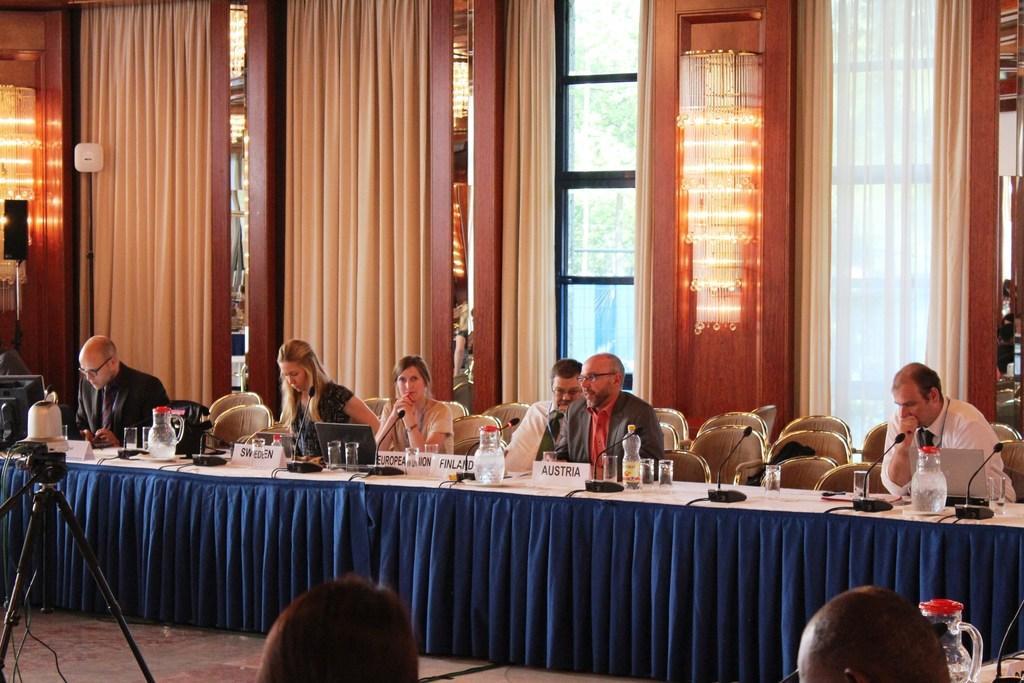Can you describe this image briefly? In this image we can see a six people who are sitting on a chair. This is a table which is covered with a cloth. In the background we can see a glass window which is bounded with a curtain. 